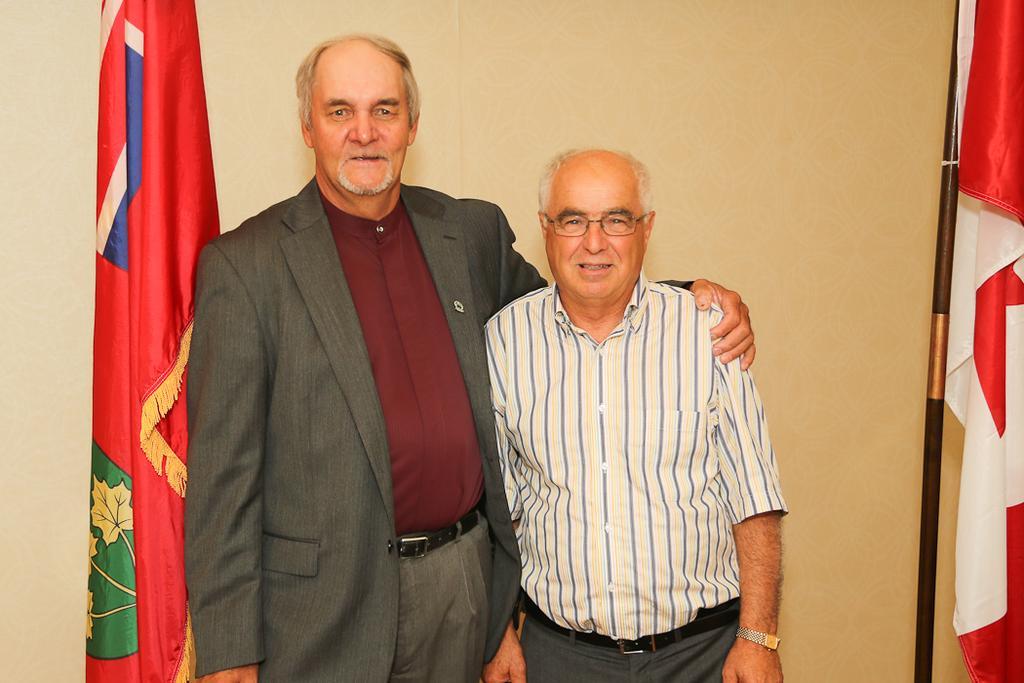Could you give a brief overview of what you see in this image? In this picture, we see two men are standing. The man on the right side is wearing the spectacles. Both of them are smiling and they are posing for the photo. On the left side, we see a flag in red, green, yellow, white and blue color. On the right side, we see a flag pole and a flag in white and red color. In the background, we see a wall. 